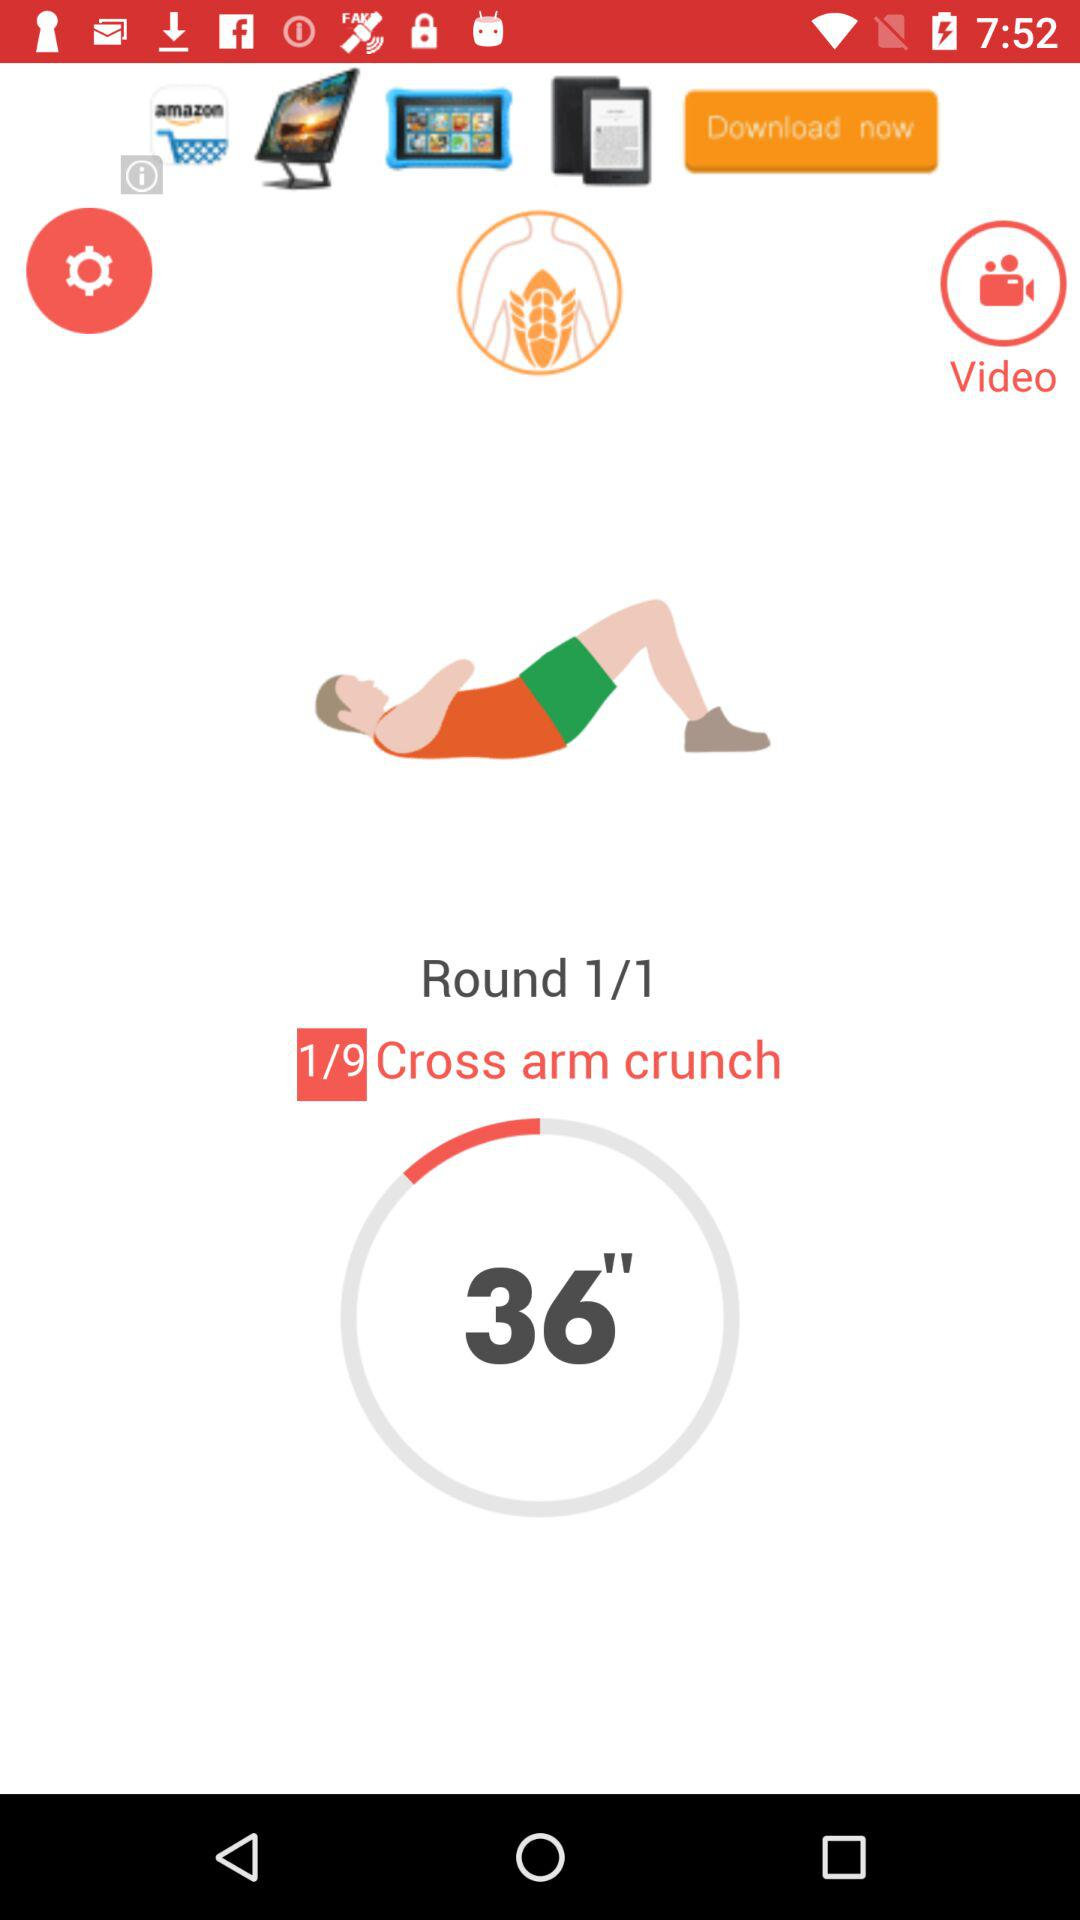What's the total count of exercises? The total count is 9. 